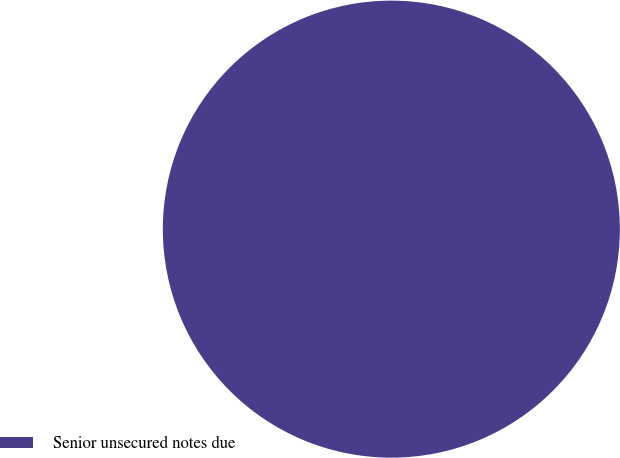Convert chart. <chart><loc_0><loc_0><loc_500><loc_500><pie_chart><fcel>Senior unsecured notes due<nl><fcel>100.0%<nl></chart> 